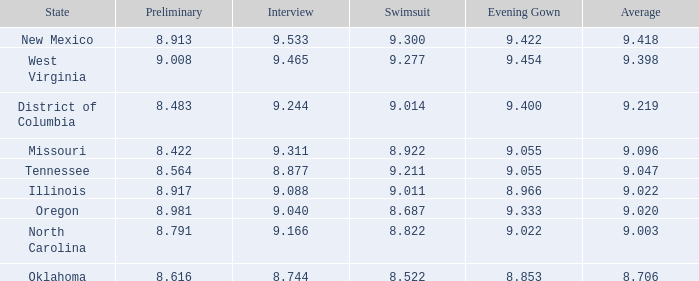Which swimsuit is specifically for oregon? 8.687. 